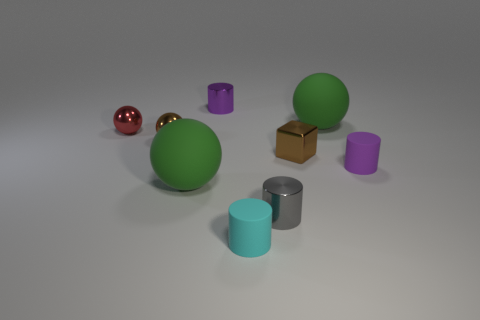Subtract all gray shiny cylinders. How many cylinders are left? 3 Subtract 1 cylinders. How many cylinders are left? 3 Subtract all cyan cylinders. How many cylinders are left? 3 Subtract all blocks. How many objects are left? 8 Add 2 small cyan things. How many small cyan things exist? 3 Subtract 1 cyan cylinders. How many objects are left? 8 Subtract all yellow cylinders. Subtract all purple spheres. How many cylinders are left? 4 Subtract all cyan blocks. How many purple cylinders are left? 2 Subtract all small red balls. Subtract all purple metal cylinders. How many objects are left? 7 Add 6 cyan rubber objects. How many cyan rubber objects are left? 7 